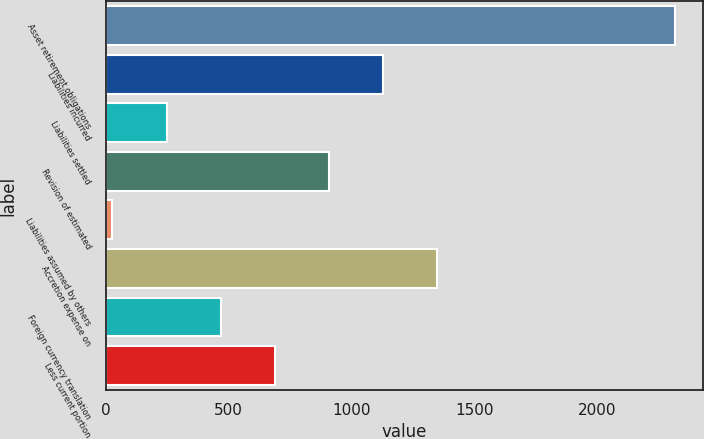Convert chart to OTSL. <chart><loc_0><loc_0><loc_500><loc_500><bar_chart><fcel>Asset retirement obligations<fcel>Liabilities incurred<fcel>Liabilities settled<fcel>Revision of estimated<fcel>Liabilities assumed by others<fcel>Accretion expense on<fcel>Foreign currency translation<fcel>Less current portion<nl><fcel>2315<fcel>1128<fcel>248<fcel>908<fcel>28<fcel>1348<fcel>468<fcel>688<nl></chart> 